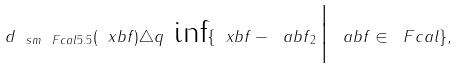Convert formula to latex. <formula><loc_0><loc_0><loc_500><loc_500>d _ { \ s m { \ F c a l } { 5 . 5 } } ( \ x b f ) \triangle q \text { inf} \{ \| \ x b f - \ a b f { \| } _ { 2 } \, \Big | \, \ a b f \in \ F c a l \} ,</formula> 